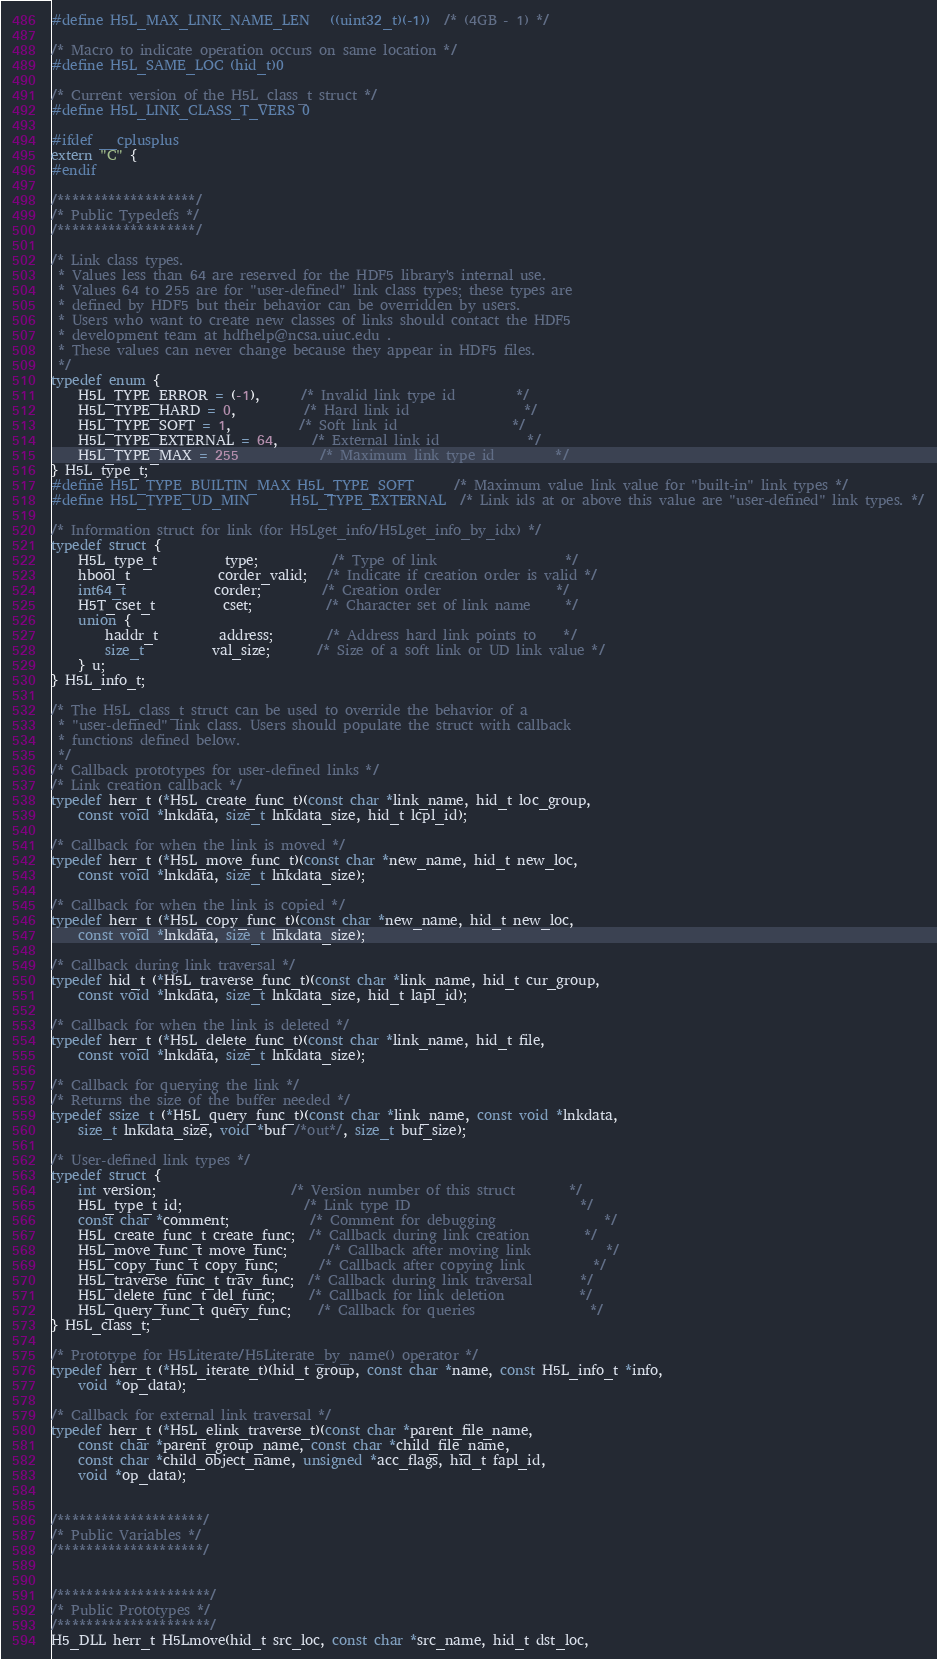<code> <loc_0><loc_0><loc_500><loc_500><_C_>#define H5L_MAX_LINK_NAME_LEN   ((uint32_t)(-1))  /* (4GB - 1) */

/* Macro to indicate operation occurs on same location */
#define H5L_SAME_LOC (hid_t)0

/* Current version of the H5L_class_t struct */
#define H5L_LINK_CLASS_T_VERS 0

#ifdef __cplusplus
extern "C" {
#endif

/*******************/
/* Public Typedefs */
/*******************/

/* Link class types.
 * Values less than 64 are reserved for the HDF5 library's internal use.
 * Values 64 to 255 are for "user-defined" link class types; these types are
 * defined by HDF5 but their behavior can be overridden by users.
 * Users who want to create new classes of links should contact the HDF5
 * development team at hdfhelp@ncsa.uiuc.edu .
 * These values can never change because they appear in HDF5 files.
 */
typedef enum {
    H5L_TYPE_ERROR = (-1),      /* Invalid link type id         */
    H5L_TYPE_HARD = 0,          /* Hard link id                 */
    H5L_TYPE_SOFT = 1,          /* Soft link id                 */
    H5L_TYPE_EXTERNAL = 64,     /* External link id             */
    H5L_TYPE_MAX = 255	        /* Maximum link type id         */
} H5L_type_t;
#define H5L_TYPE_BUILTIN_MAX H5L_TYPE_SOFT      /* Maximum value link value for "built-in" link types */
#define H5L_TYPE_UD_MIN      H5L_TYPE_EXTERNAL  /* Link ids at or above this value are "user-defined" link types. */

/* Information struct for link (for H5Lget_info/H5Lget_info_by_idx) */
typedef struct {
    H5L_type_t          type;           /* Type of link                   */
    hbool_t             corder_valid;   /* Indicate if creation order is valid */
    int64_t             corder;         /* Creation order                 */
    H5T_cset_t          cset;           /* Character set of link name     */
    union {
        haddr_t         address;        /* Address hard link points to    */
        size_t          val_size;       /* Size of a soft link or UD link value */
    } u;
} H5L_info_t;

/* The H5L_class_t struct can be used to override the behavior of a
 * "user-defined" link class. Users should populate the struct with callback
 * functions defined below.
 */
/* Callback prototypes for user-defined links */
/* Link creation callback */
typedef herr_t (*H5L_create_func_t)(const char *link_name, hid_t loc_group,
    const void *lnkdata, size_t lnkdata_size, hid_t lcpl_id);

/* Callback for when the link is moved */
typedef herr_t (*H5L_move_func_t)(const char *new_name, hid_t new_loc,
    const void *lnkdata, size_t lnkdata_size);

/* Callback for when the link is copied */
typedef herr_t (*H5L_copy_func_t)(const char *new_name, hid_t new_loc,
    const void *lnkdata, size_t lnkdata_size);

/* Callback during link traversal */
typedef hid_t (*H5L_traverse_func_t)(const char *link_name, hid_t cur_group,
    const void *lnkdata, size_t lnkdata_size, hid_t lapl_id);

/* Callback for when the link is deleted */
typedef herr_t (*H5L_delete_func_t)(const char *link_name, hid_t file,
    const void *lnkdata, size_t lnkdata_size);

/* Callback for querying the link */
/* Returns the size of the buffer needed */
typedef ssize_t (*H5L_query_func_t)(const char *link_name, const void *lnkdata,
    size_t lnkdata_size, void *buf /*out*/, size_t buf_size);

/* User-defined link types */
typedef struct {
    int version;                    /* Version number of this struct        */
    H5L_type_t id;                  /* Link type ID                         */
    const char *comment;            /* Comment for debugging                */
    H5L_create_func_t create_func;  /* Callback during link creation        */
    H5L_move_func_t move_func;      /* Callback after moving link           */
    H5L_copy_func_t copy_func;      /* Callback after copying link          */
    H5L_traverse_func_t trav_func;  /* Callback during link traversal       */
    H5L_delete_func_t del_func;     /* Callback for link deletion           */
    H5L_query_func_t query_func;    /* Callback for queries                 */
} H5L_class_t;

/* Prototype for H5Literate/H5Literate_by_name() operator */
typedef herr_t (*H5L_iterate_t)(hid_t group, const char *name, const H5L_info_t *info,
    void *op_data);

/* Callback for external link traversal */
typedef herr_t (*H5L_elink_traverse_t)(const char *parent_file_name,
    const char *parent_group_name, const char *child_file_name,
    const char *child_object_name, unsigned *acc_flags, hid_t fapl_id,
    void *op_data);


/********************/
/* Public Variables */
/********************/


/*********************/
/* Public Prototypes */
/*********************/
H5_DLL herr_t H5Lmove(hid_t src_loc, const char *src_name, hid_t dst_loc,</code> 